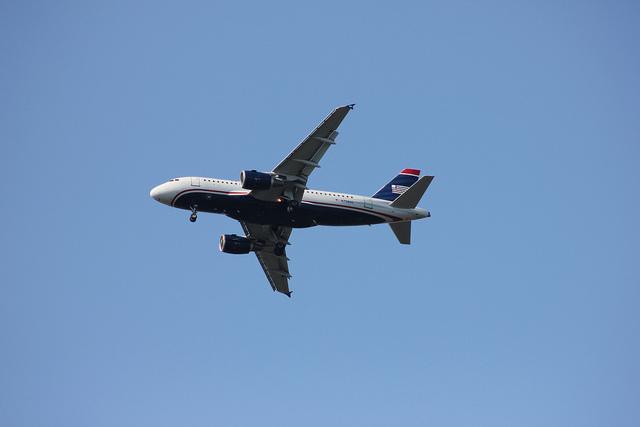Does the plane have more than one color?
Keep it brief. Yes. How many windows are visible on the plane?
Answer briefly. 18. Is this plane landing?
Write a very short answer. No. 